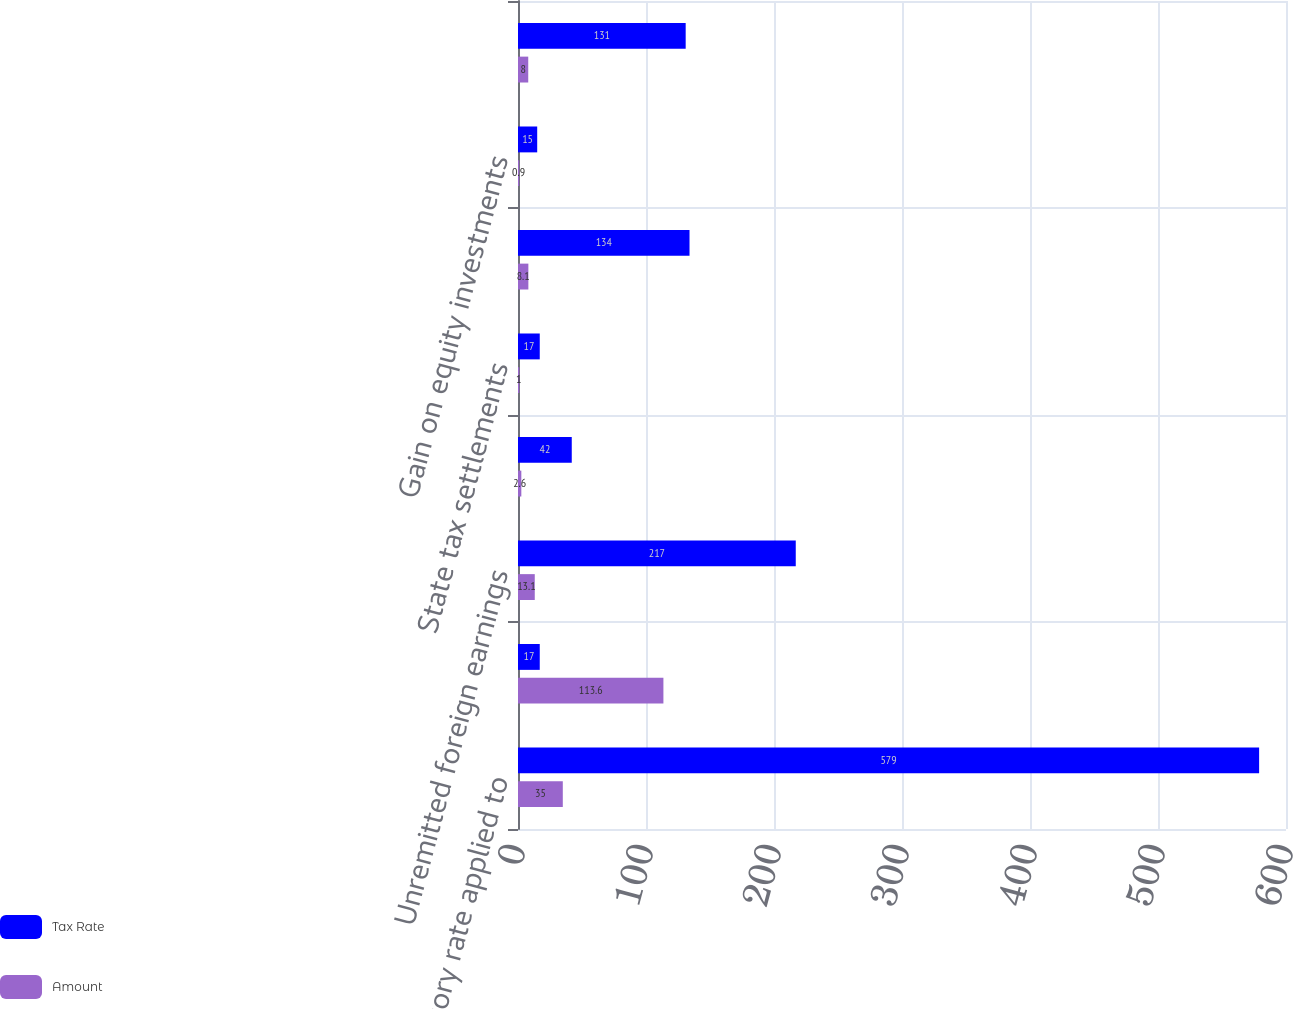Convert chart to OTSL. <chart><loc_0><loc_0><loc_500><loc_500><stacked_bar_chart><ecel><fcel>US statutory rate applied to<fcel>Foreign earnings<fcel>Unremitted foreign earnings<fcel>State taxes<fcel>State tax settlements<fcel>Restructuring<fcel>Gain on equity investments<fcel>Other (1)<nl><fcel>Tax Rate<fcel>579<fcel>17<fcel>217<fcel>42<fcel>17<fcel>134<fcel>15<fcel>131<nl><fcel>Amount<fcel>35<fcel>113.6<fcel>13.1<fcel>2.6<fcel>1<fcel>8.1<fcel>0.9<fcel>8<nl></chart> 